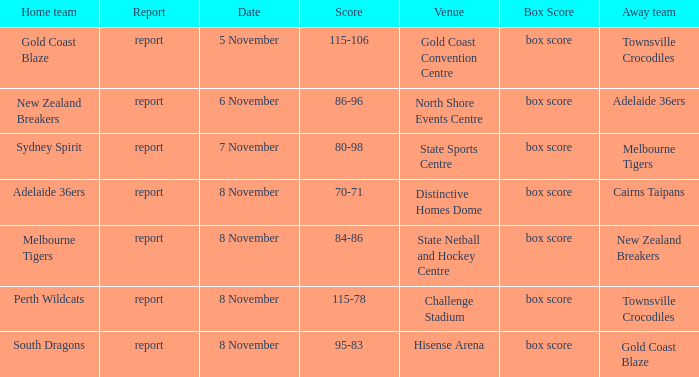What was the report at State Sports Centre? Report. 